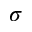<formula> <loc_0><loc_0><loc_500><loc_500>\sigma</formula> 